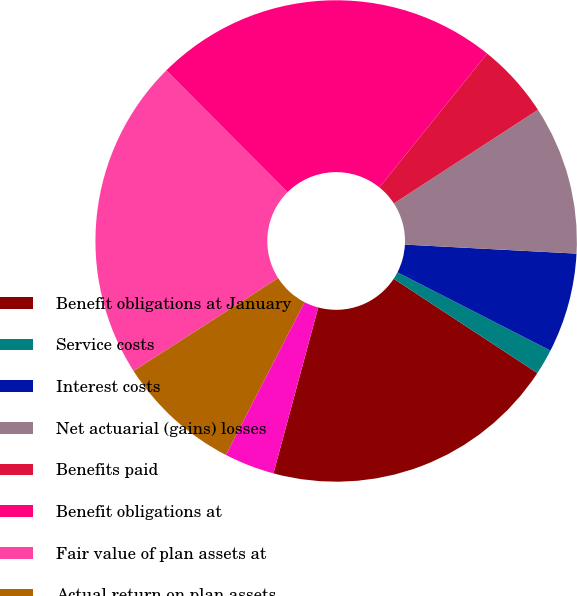Convert chart to OTSL. <chart><loc_0><loc_0><loc_500><loc_500><pie_chart><fcel>Benefit obligations at January<fcel>Service costs<fcel>Interest costs<fcel>Net actuarial (gains) losses<fcel>Benefits paid<fcel>Benefit obligations at<fcel>Fair value of plan assets at<fcel>Actual return on plan assets<fcel>Employer contributions<nl><fcel>19.95%<fcel>1.72%<fcel>6.69%<fcel>10.01%<fcel>5.03%<fcel>23.27%<fcel>21.61%<fcel>8.35%<fcel>3.38%<nl></chart> 